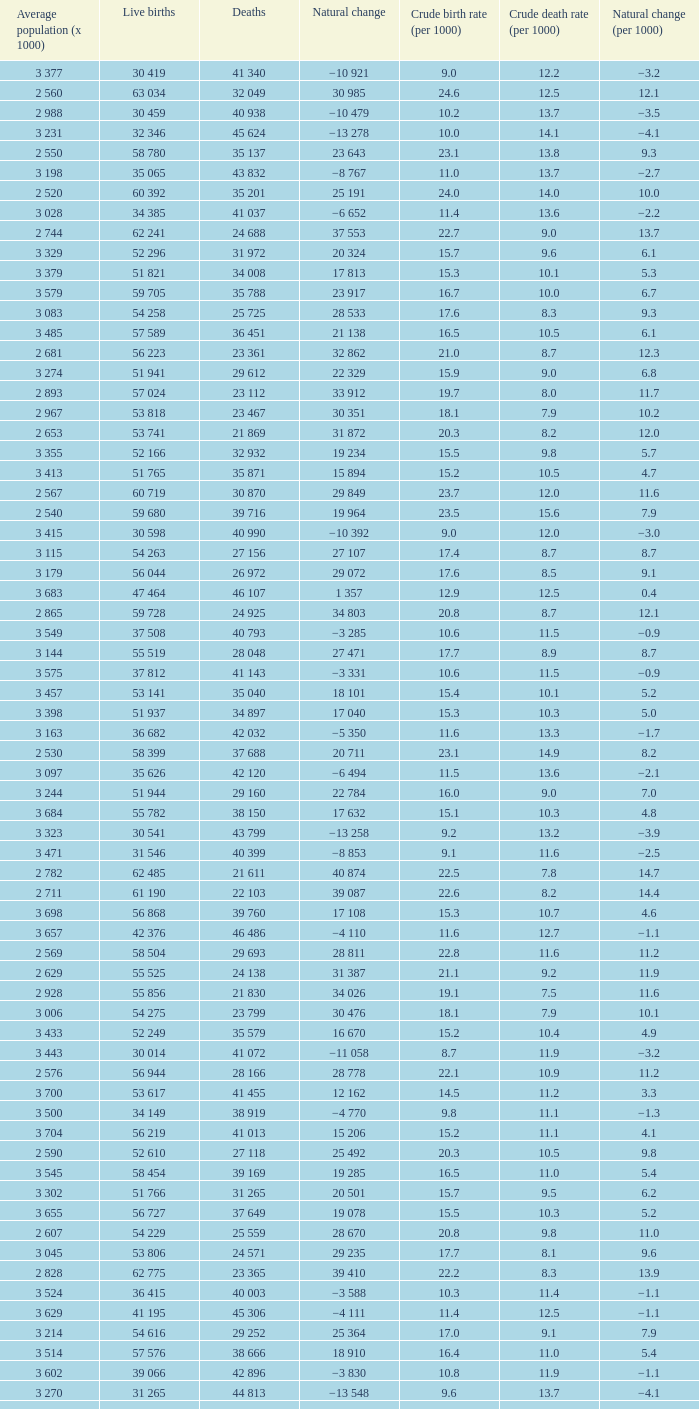Which Average population (x 1000) has a Crude death rate (per 1000) smaller than 10.9, and a Crude birth rate (per 1000) smaller than 19.7, and a Natural change (per 1000) of 8.7, and Live births of 54 263? 3 115. 